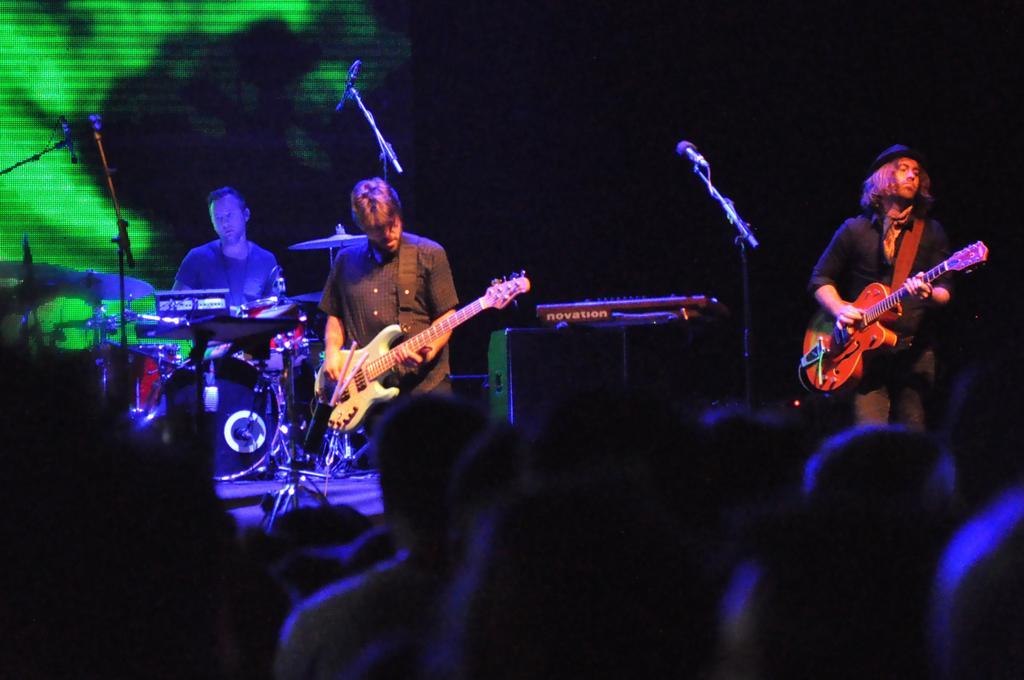What is happening on the stage in the image? There are three people performing on a stage. What instruments are being played by the performers? One performer is playing a guitar, and another is playing a snare drum. Can you describe the audience in the image? There are people watching the performance. What type of pig can be seen performing with the musicians in the image? There is no pig present in the image; the performers are playing musical instruments. 